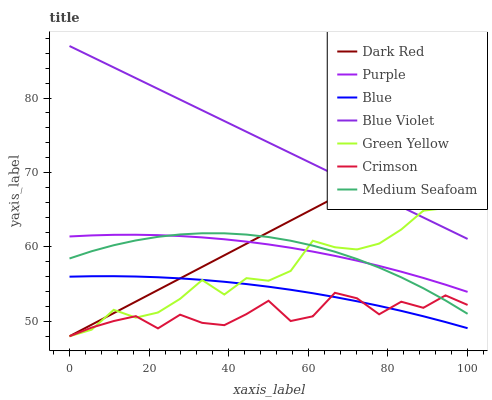Does Crimson have the minimum area under the curve?
Answer yes or no. Yes. Does Blue Violet have the maximum area under the curve?
Answer yes or no. Yes. Does Purple have the minimum area under the curve?
Answer yes or no. No. Does Purple have the maximum area under the curve?
Answer yes or no. No. Is Dark Red the smoothest?
Answer yes or no. Yes. Is Crimson the roughest?
Answer yes or no. Yes. Is Purple the smoothest?
Answer yes or no. No. Is Purple the roughest?
Answer yes or no. No. Does Dark Red have the lowest value?
Answer yes or no. Yes. Does Purple have the lowest value?
Answer yes or no. No. Does Blue Violet have the highest value?
Answer yes or no. Yes. Does Purple have the highest value?
Answer yes or no. No. Is Crimson less than Purple?
Answer yes or no. Yes. Is Blue Violet greater than Purple?
Answer yes or no. Yes. Does Green Yellow intersect Purple?
Answer yes or no. Yes. Is Green Yellow less than Purple?
Answer yes or no. No. Is Green Yellow greater than Purple?
Answer yes or no. No. Does Crimson intersect Purple?
Answer yes or no. No. 